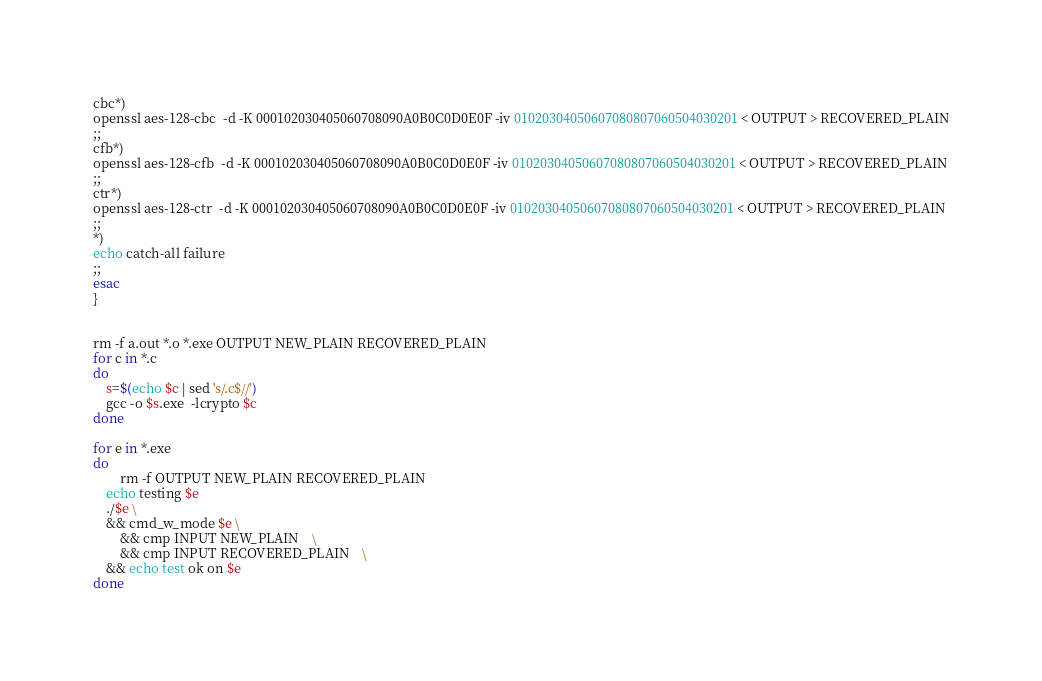Convert code to text. <code><loc_0><loc_0><loc_500><loc_500><_Bash_>cbc*)
openssl aes-128-cbc  -d -K 000102030405060708090A0B0C0D0E0F -iv 01020304050607080807060504030201 < OUTPUT > RECOVERED_PLAIN
;;
cfb*)
openssl aes-128-cfb  -d -K 000102030405060708090A0B0C0D0E0F -iv 01020304050607080807060504030201 < OUTPUT > RECOVERED_PLAIN
;;
ctr*)
openssl aes-128-ctr  -d -K 000102030405060708090A0B0C0D0E0F -iv 01020304050607080807060504030201 < OUTPUT > RECOVERED_PLAIN
;;
*)
echo catch-all failure
;;
esac
}


rm -f a.out *.o *.exe OUTPUT NEW_PLAIN RECOVERED_PLAIN
for c in *.c
do
    s=$(echo $c | sed 's/.c$//')
    gcc -o $s.exe  -lcrypto $c
done

for e in *.exe
do
        rm -f OUTPUT NEW_PLAIN RECOVERED_PLAIN
	echo testing $e
	./$e \
	&& cmd_w_mode $e \
        && cmp INPUT NEW_PLAIN    \
        && cmp INPUT RECOVERED_PLAIN    \
	&& echo test ok on $e
done
</code> 